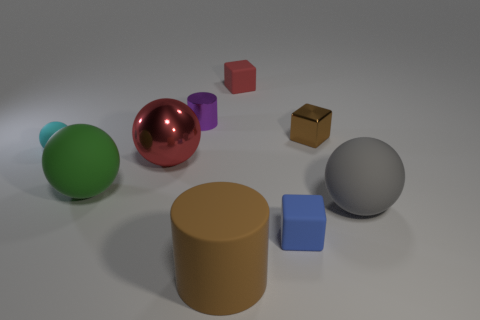What material is the brown object that is the same shape as the tiny red rubber thing?
Offer a terse response. Metal. Do the gray thing and the tiny purple cylinder have the same material?
Offer a very short reply. No. What color is the rubber block behind the big rubber thing that is left of the brown matte thing?
Ensure brevity in your answer.  Red. There is a cylinder that is the same material as the large red sphere; what size is it?
Make the answer very short. Small. What number of red things are the same shape as the tiny brown thing?
Ensure brevity in your answer.  1. How many objects are either tiny matte blocks that are in front of the tiny metallic cube or things that are left of the large gray ball?
Your answer should be compact. 8. There is a rubber block behind the small shiny cylinder; what number of cyan matte balls are left of it?
Make the answer very short. 1. Is the shape of the large metallic object behind the large brown cylinder the same as the big rubber object on the right side of the brown matte cylinder?
Offer a terse response. Yes. What shape is the other object that is the same color as the big metal object?
Make the answer very short. Cube. Is there a tiny ball that has the same material as the purple object?
Offer a terse response. No. 